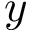Convert formula to latex. <formula><loc_0><loc_0><loc_500><loc_500>y</formula> 